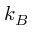<formula> <loc_0><loc_0><loc_500><loc_500>k _ { B }</formula> 